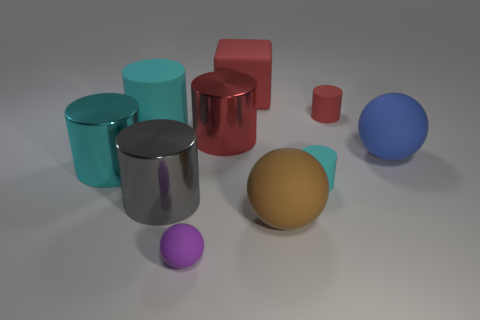Do the brown ball and the purple ball have the same size?
Provide a short and direct response. No. What is the color of the large matte object left of the red thing behind the red object that is right of the large brown rubber thing?
Your response must be concise. Cyan. What number of metal objects are the same color as the rubber block?
Offer a terse response. 1. How many tiny things are gray metal cylinders or blue spheres?
Make the answer very short. 0. Is there another big gray thing that has the same shape as the big gray shiny thing?
Offer a terse response. No. Is the tiny red matte object the same shape as the large gray object?
Offer a terse response. Yes. What is the color of the sphere behind the big shiny thing that is on the left side of the large gray metallic object?
Your response must be concise. Blue. There is a matte cube that is the same size as the gray metal thing; what is its color?
Give a very brief answer. Red. What number of matte objects are either large blue objects or cyan objects?
Your answer should be very brief. 3. What number of small cyan cylinders are on the left side of the cyan matte cylinder in front of the cyan metallic cylinder?
Offer a terse response. 0. 